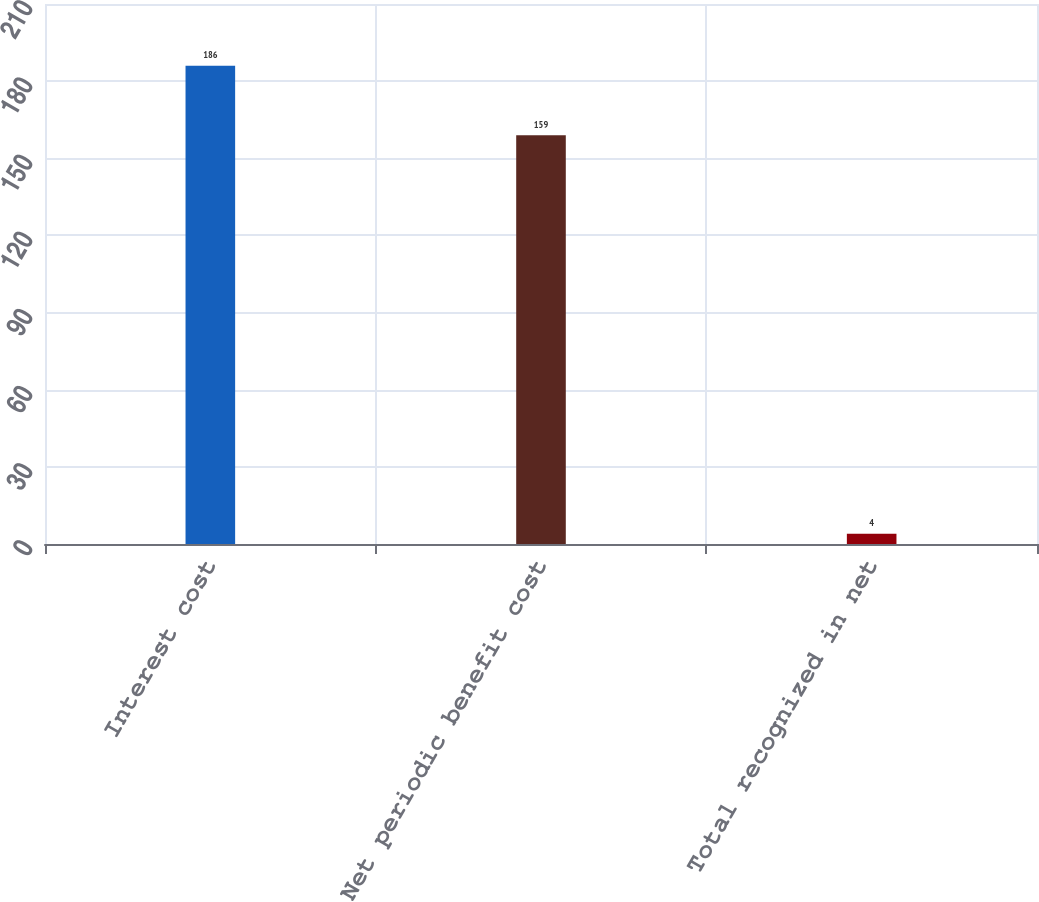<chart> <loc_0><loc_0><loc_500><loc_500><bar_chart><fcel>Interest cost<fcel>Net periodic benefit cost<fcel>Total recognized in net<nl><fcel>186<fcel>159<fcel>4<nl></chart> 